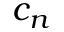Convert formula to latex. <formula><loc_0><loc_0><loc_500><loc_500>c _ { n }</formula> 